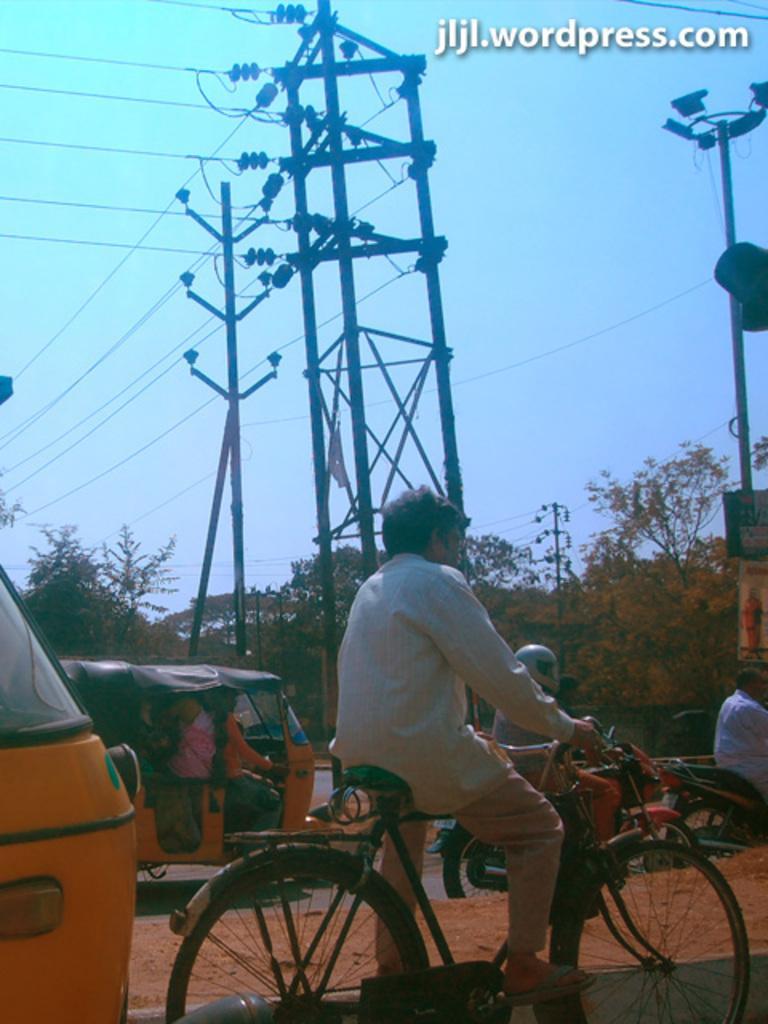Describe this image in one or two sentences. A vehicles on road. This man is riding a bicycle. This is a current pole with cables. Far there are trees. 